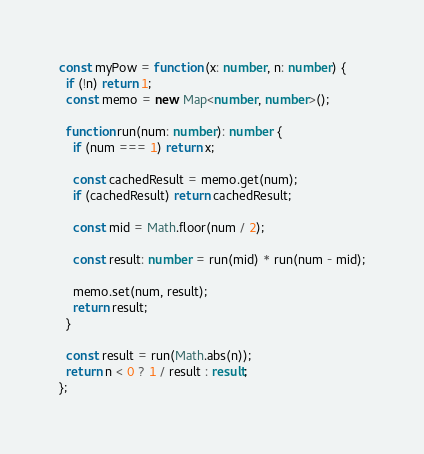Convert code to text. <code><loc_0><loc_0><loc_500><loc_500><_TypeScript_>const myPow = function (x: number, n: number) {
  if (!n) return 1;
  const memo = new Map<number, number>();

  function run(num: number): number {
    if (num === 1) return x;

    const cachedResult = memo.get(num);
    if (cachedResult) return cachedResult;

    const mid = Math.floor(num / 2);

    const result: number = run(mid) * run(num - mid);

    memo.set(num, result);
    return result;
  }

  const result = run(Math.abs(n));
  return n < 0 ? 1 / result : result;
};
</code> 